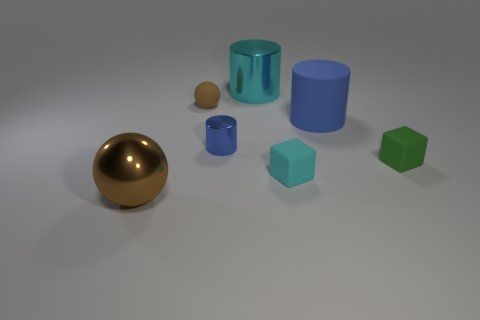Add 1 large blue cylinders. How many objects exist? 8 Subtract all balls. How many objects are left? 5 Subtract 0 red cylinders. How many objects are left? 7 Subtract all large brown matte spheres. Subtract all small blue objects. How many objects are left? 6 Add 1 tiny brown matte balls. How many tiny brown matte balls are left? 2 Add 6 brown metallic balls. How many brown metallic balls exist? 7 